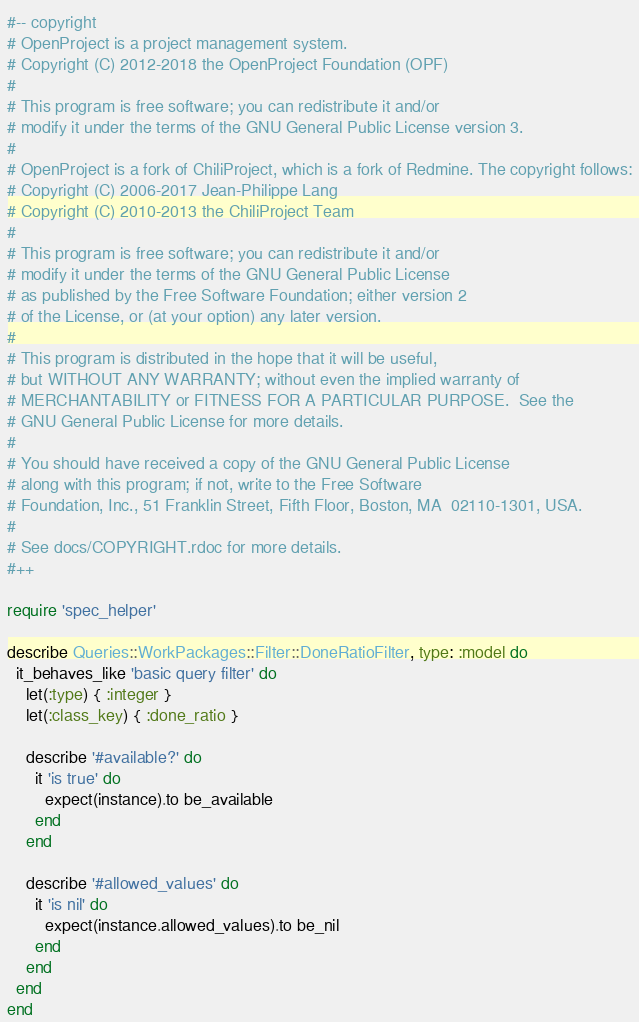<code> <loc_0><loc_0><loc_500><loc_500><_Ruby_>#-- copyright
# OpenProject is a project management system.
# Copyright (C) 2012-2018 the OpenProject Foundation (OPF)
#
# This program is free software; you can redistribute it and/or
# modify it under the terms of the GNU General Public License version 3.
#
# OpenProject is a fork of ChiliProject, which is a fork of Redmine. The copyright follows:
# Copyright (C) 2006-2017 Jean-Philippe Lang
# Copyright (C) 2010-2013 the ChiliProject Team
#
# This program is free software; you can redistribute it and/or
# modify it under the terms of the GNU General Public License
# as published by the Free Software Foundation; either version 2
# of the License, or (at your option) any later version.
#
# This program is distributed in the hope that it will be useful,
# but WITHOUT ANY WARRANTY; without even the implied warranty of
# MERCHANTABILITY or FITNESS FOR A PARTICULAR PURPOSE.  See the
# GNU General Public License for more details.
#
# You should have received a copy of the GNU General Public License
# along with this program; if not, write to the Free Software
# Foundation, Inc., 51 Franklin Street, Fifth Floor, Boston, MA  02110-1301, USA.
#
# See docs/COPYRIGHT.rdoc for more details.
#++

require 'spec_helper'

describe Queries::WorkPackages::Filter::DoneRatioFilter, type: :model do
  it_behaves_like 'basic query filter' do
    let(:type) { :integer }
    let(:class_key) { :done_ratio }

    describe '#available?' do
      it 'is true' do
        expect(instance).to be_available
      end
    end

    describe '#allowed_values' do
      it 'is nil' do
        expect(instance.allowed_values).to be_nil
      end
    end
  end
end
</code> 